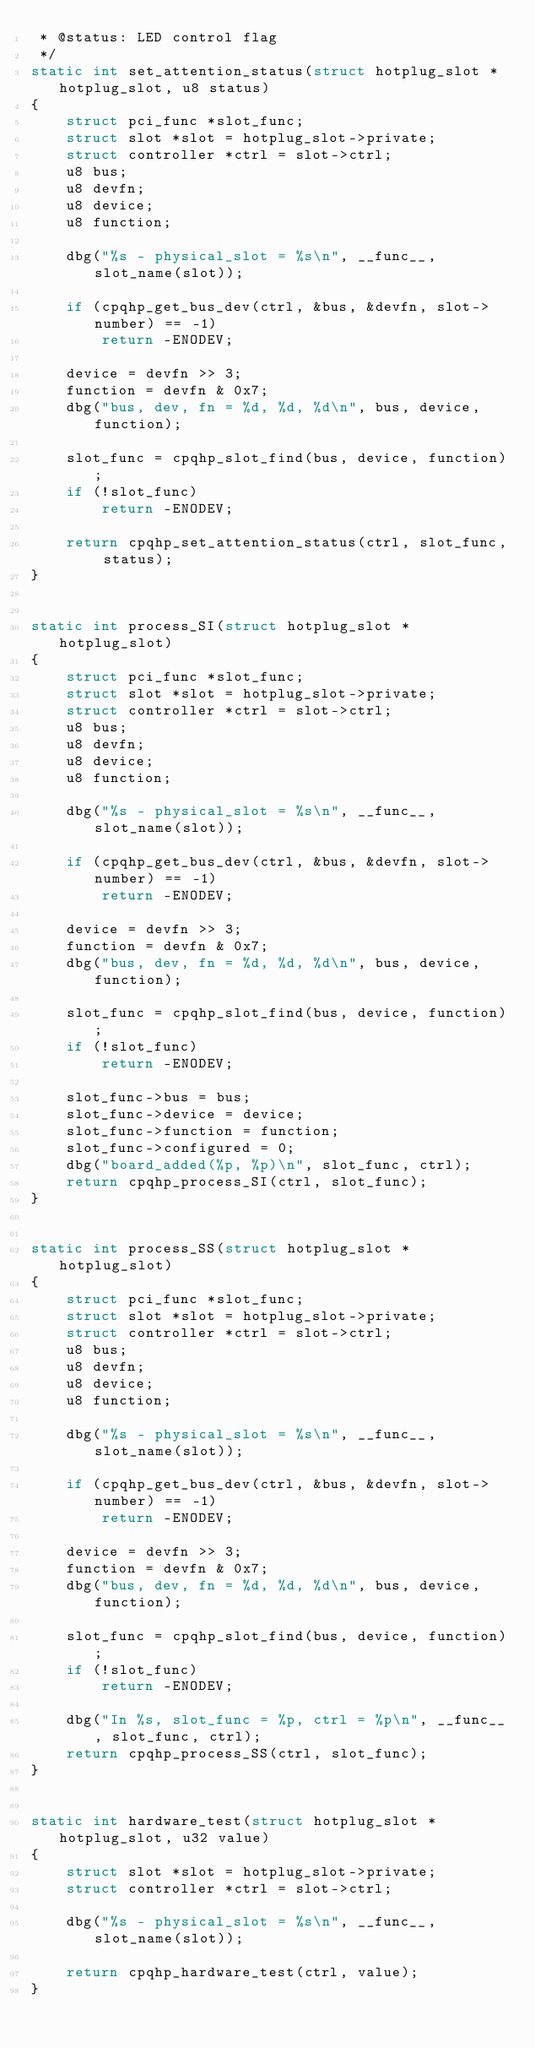<code> <loc_0><loc_0><loc_500><loc_500><_C_> * @status: LED control flag
 */
static int set_attention_status(struct hotplug_slot *hotplug_slot, u8 status)
{
	struct pci_func *slot_func;
	struct slot *slot = hotplug_slot->private;
	struct controller *ctrl = slot->ctrl;
	u8 bus;
	u8 devfn;
	u8 device;
	u8 function;

	dbg("%s - physical_slot = %s\n", __func__, slot_name(slot));

	if (cpqhp_get_bus_dev(ctrl, &bus, &devfn, slot->number) == -1)
		return -ENODEV;

	device = devfn >> 3;
	function = devfn & 0x7;
	dbg("bus, dev, fn = %d, %d, %d\n", bus, device, function);

	slot_func = cpqhp_slot_find(bus, device, function);
	if (!slot_func)
		return -ENODEV;

	return cpqhp_set_attention_status(ctrl, slot_func, status);
}


static int process_SI(struct hotplug_slot *hotplug_slot)
{
	struct pci_func *slot_func;
	struct slot *slot = hotplug_slot->private;
	struct controller *ctrl = slot->ctrl;
	u8 bus;
	u8 devfn;
	u8 device;
	u8 function;

	dbg("%s - physical_slot = %s\n", __func__, slot_name(slot));

	if (cpqhp_get_bus_dev(ctrl, &bus, &devfn, slot->number) == -1)
		return -ENODEV;

	device = devfn >> 3;
	function = devfn & 0x7;
	dbg("bus, dev, fn = %d, %d, %d\n", bus, device, function);

	slot_func = cpqhp_slot_find(bus, device, function);
	if (!slot_func)
		return -ENODEV;

	slot_func->bus = bus;
	slot_func->device = device;
	slot_func->function = function;
	slot_func->configured = 0;
	dbg("board_added(%p, %p)\n", slot_func, ctrl);
	return cpqhp_process_SI(ctrl, slot_func);
}


static int process_SS(struct hotplug_slot *hotplug_slot)
{
	struct pci_func *slot_func;
	struct slot *slot = hotplug_slot->private;
	struct controller *ctrl = slot->ctrl;
	u8 bus;
	u8 devfn;
	u8 device;
	u8 function;

	dbg("%s - physical_slot = %s\n", __func__, slot_name(slot));

	if (cpqhp_get_bus_dev(ctrl, &bus, &devfn, slot->number) == -1)
		return -ENODEV;

	device = devfn >> 3;
	function = devfn & 0x7;
	dbg("bus, dev, fn = %d, %d, %d\n", bus, device, function);

	slot_func = cpqhp_slot_find(bus, device, function);
	if (!slot_func)
		return -ENODEV;

	dbg("In %s, slot_func = %p, ctrl = %p\n", __func__, slot_func, ctrl);
	return cpqhp_process_SS(ctrl, slot_func);
}


static int hardware_test(struct hotplug_slot *hotplug_slot, u32 value)
{
	struct slot *slot = hotplug_slot->private;
	struct controller *ctrl = slot->ctrl;

	dbg("%s - physical_slot = %s\n", __func__, slot_name(slot));

	return cpqhp_hardware_test(ctrl, value);
}

</code> 